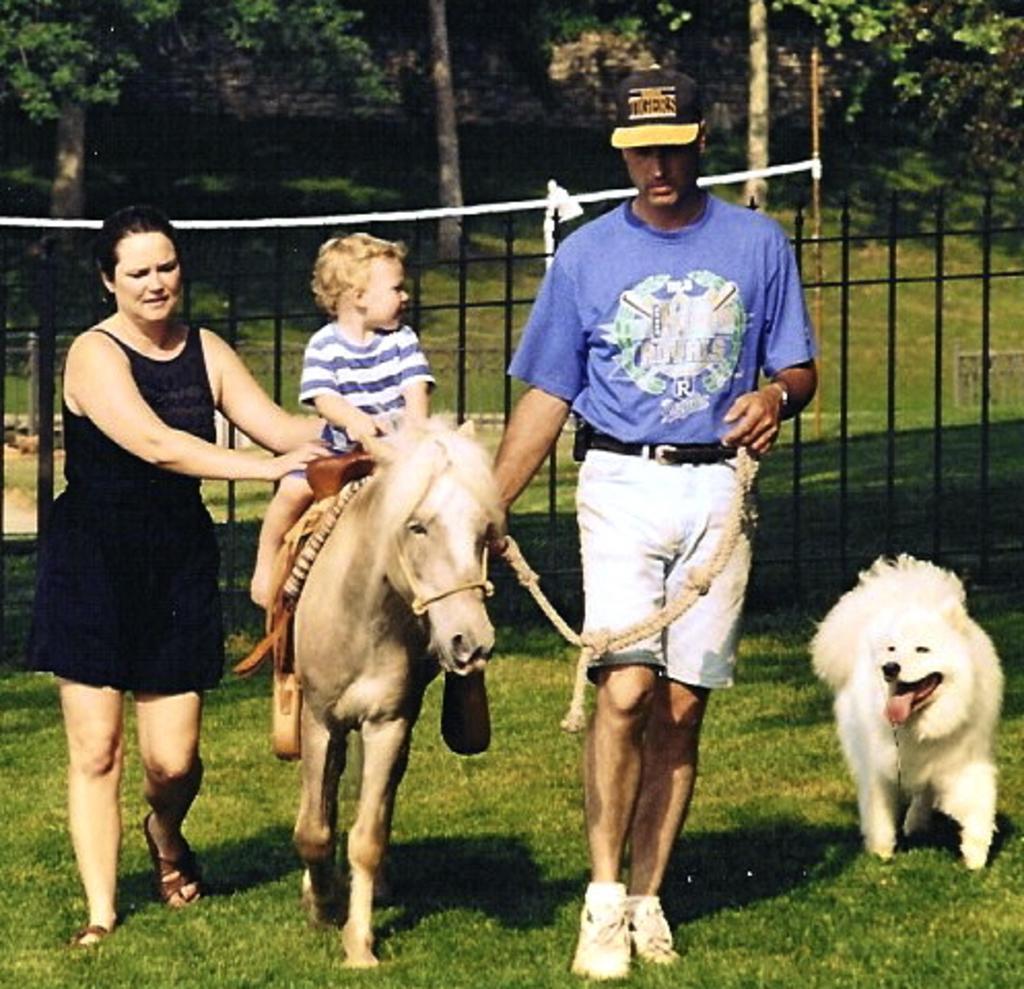Could you give a brief overview of what you see in this image? In this picture there is a woman and a man walking. There is a boy sitting on the horse. In the right side there is a dog walking on the grass. In the background there is railing and some trees here. 